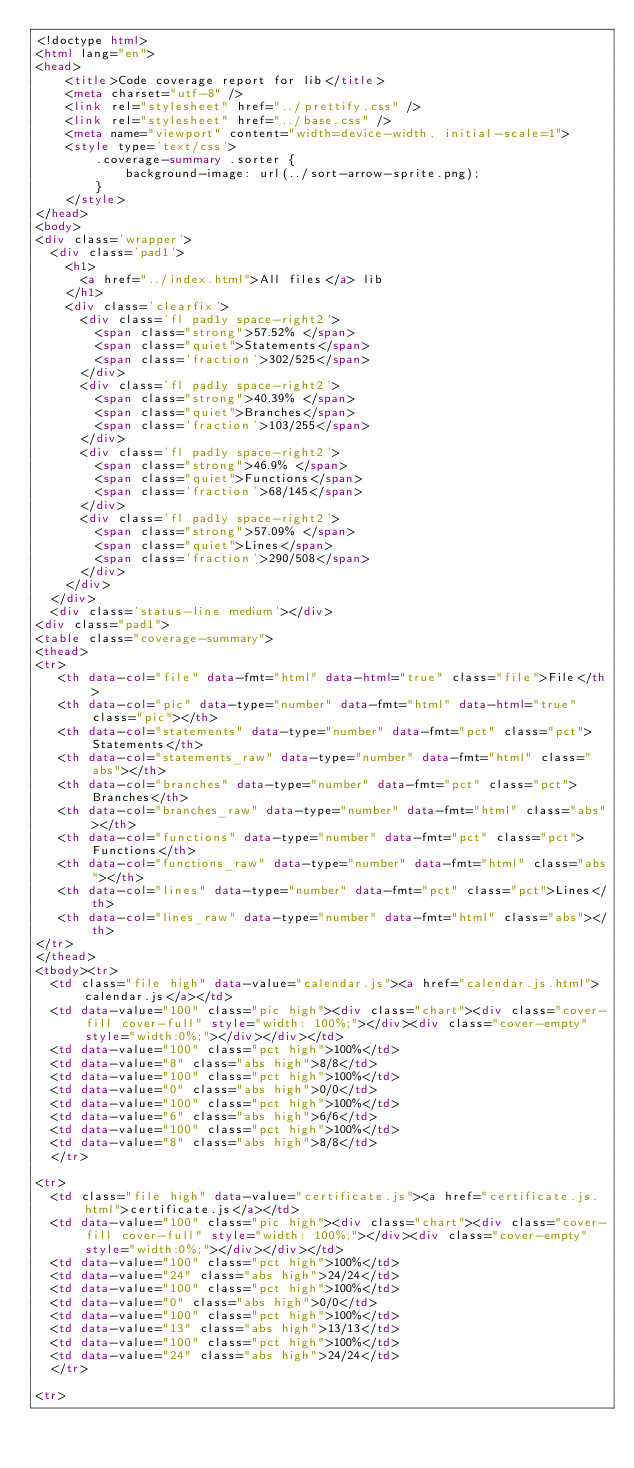Convert code to text. <code><loc_0><loc_0><loc_500><loc_500><_HTML_><!doctype html>
<html lang="en">
<head>
    <title>Code coverage report for lib</title>
    <meta charset="utf-8" />
    <link rel="stylesheet" href="../prettify.css" />
    <link rel="stylesheet" href="../base.css" />
    <meta name="viewport" content="width=device-width, initial-scale=1">
    <style type='text/css'>
        .coverage-summary .sorter {
            background-image: url(../sort-arrow-sprite.png);
        }
    </style>
</head>
<body>
<div class='wrapper'>
  <div class='pad1'>
    <h1>
      <a href="../index.html">All files</a> lib
    </h1>
    <div class='clearfix'>
      <div class='fl pad1y space-right2'>
        <span class="strong">57.52% </span>
        <span class="quiet">Statements</span>
        <span class='fraction'>302/525</span>
      </div>
      <div class='fl pad1y space-right2'>
        <span class="strong">40.39% </span>
        <span class="quiet">Branches</span>
        <span class='fraction'>103/255</span>
      </div>
      <div class='fl pad1y space-right2'>
        <span class="strong">46.9% </span>
        <span class="quiet">Functions</span>
        <span class='fraction'>68/145</span>
      </div>
      <div class='fl pad1y space-right2'>
        <span class="strong">57.09% </span>
        <span class="quiet">Lines</span>
        <span class='fraction'>290/508</span>
      </div>
    </div>
  </div>
  <div class='status-line medium'></div>
<div class="pad1">
<table class="coverage-summary">
<thead>
<tr>
   <th data-col="file" data-fmt="html" data-html="true" class="file">File</th>
   <th data-col="pic" data-type="number" data-fmt="html" data-html="true" class="pic"></th>
   <th data-col="statements" data-type="number" data-fmt="pct" class="pct">Statements</th>
   <th data-col="statements_raw" data-type="number" data-fmt="html" class="abs"></th>
   <th data-col="branches" data-type="number" data-fmt="pct" class="pct">Branches</th>
   <th data-col="branches_raw" data-type="number" data-fmt="html" class="abs"></th>
   <th data-col="functions" data-type="number" data-fmt="pct" class="pct">Functions</th>
   <th data-col="functions_raw" data-type="number" data-fmt="html" class="abs"></th>
   <th data-col="lines" data-type="number" data-fmt="pct" class="pct">Lines</th>
   <th data-col="lines_raw" data-type="number" data-fmt="html" class="abs"></th>
</tr>
</thead>
<tbody><tr>
	<td class="file high" data-value="calendar.js"><a href="calendar.js.html">calendar.js</a></td>
	<td data-value="100" class="pic high"><div class="chart"><div class="cover-fill cover-full" style="width: 100%;"></div><div class="cover-empty" style="width:0%;"></div></div></td>
	<td data-value="100" class="pct high">100%</td>
	<td data-value="8" class="abs high">8/8</td>
	<td data-value="100" class="pct high">100%</td>
	<td data-value="0" class="abs high">0/0</td>
	<td data-value="100" class="pct high">100%</td>
	<td data-value="6" class="abs high">6/6</td>
	<td data-value="100" class="pct high">100%</td>
	<td data-value="8" class="abs high">8/8</td>
	</tr>

<tr>
	<td class="file high" data-value="certificate.js"><a href="certificate.js.html">certificate.js</a></td>
	<td data-value="100" class="pic high"><div class="chart"><div class="cover-fill cover-full" style="width: 100%;"></div><div class="cover-empty" style="width:0%;"></div></div></td>
	<td data-value="100" class="pct high">100%</td>
	<td data-value="24" class="abs high">24/24</td>
	<td data-value="100" class="pct high">100%</td>
	<td data-value="0" class="abs high">0/0</td>
	<td data-value="100" class="pct high">100%</td>
	<td data-value="13" class="abs high">13/13</td>
	<td data-value="100" class="pct high">100%</td>
	<td data-value="24" class="abs high">24/24</td>
	</tr>

<tr></code> 